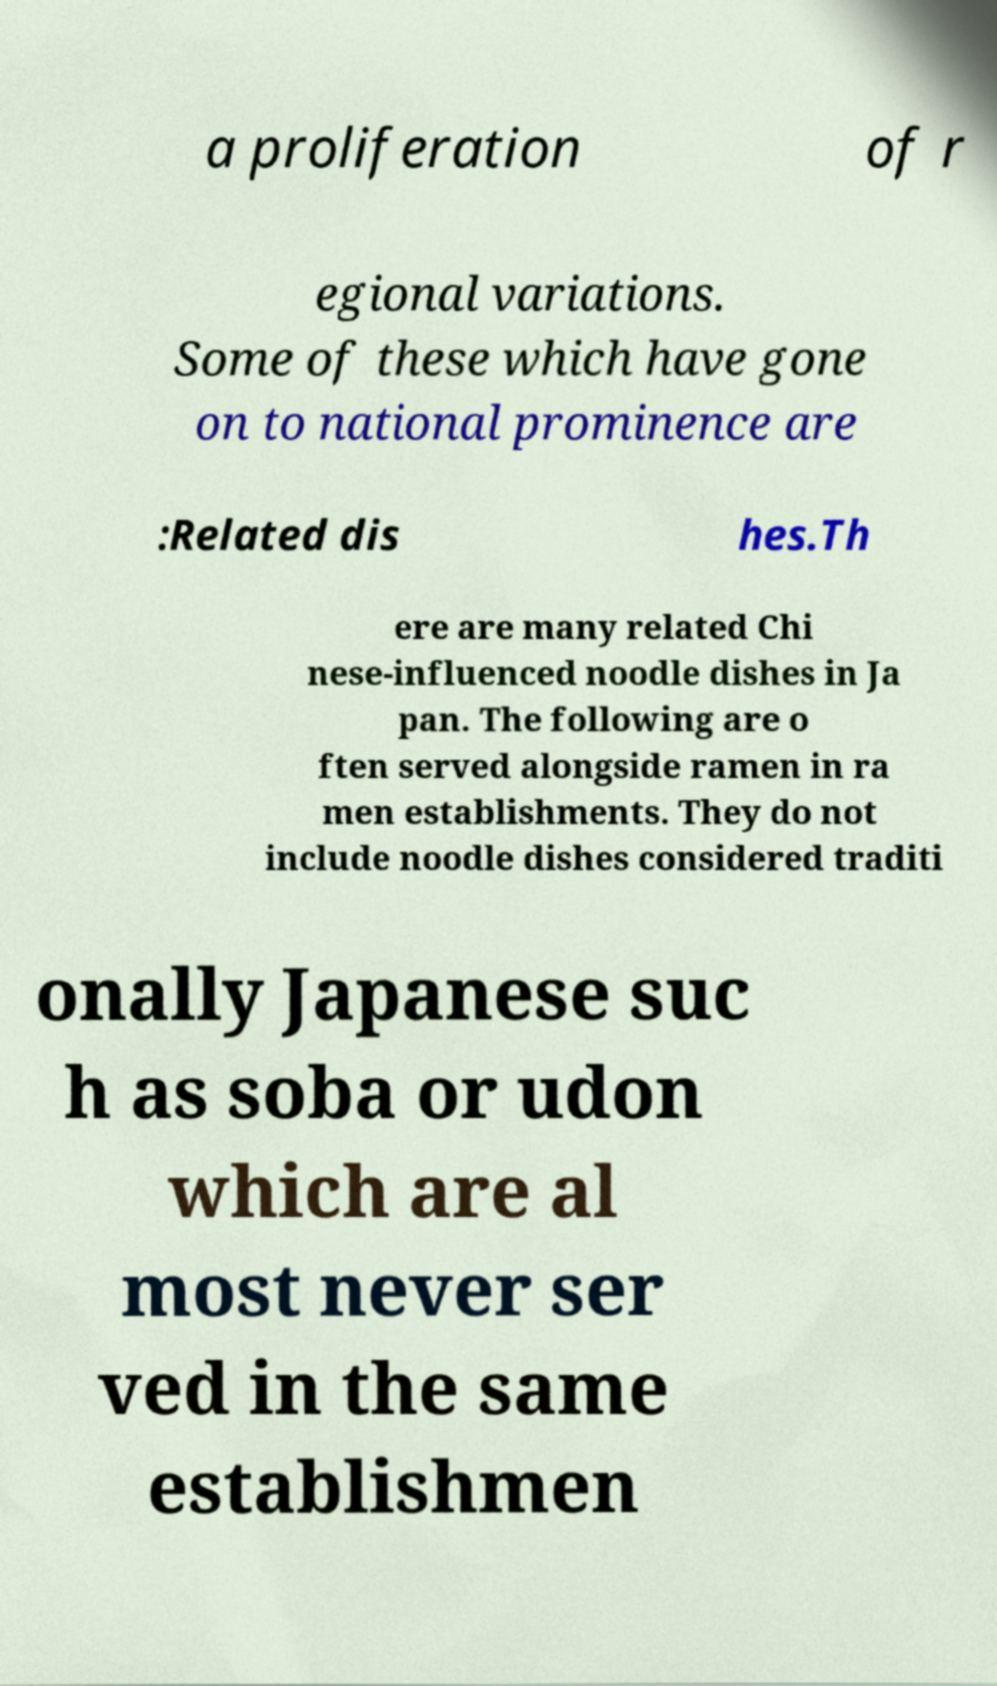I need the written content from this picture converted into text. Can you do that? a proliferation of r egional variations. Some of these which have gone on to national prominence are :Related dis hes.Th ere are many related Chi nese-influenced noodle dishes in Ja pan. The following are o ften served alongside ramen in ra men establishments. They do not include noodle dishes considered traditi onally Japanese suc h as soba or udon which are al most never ser ved in the same establishmen 